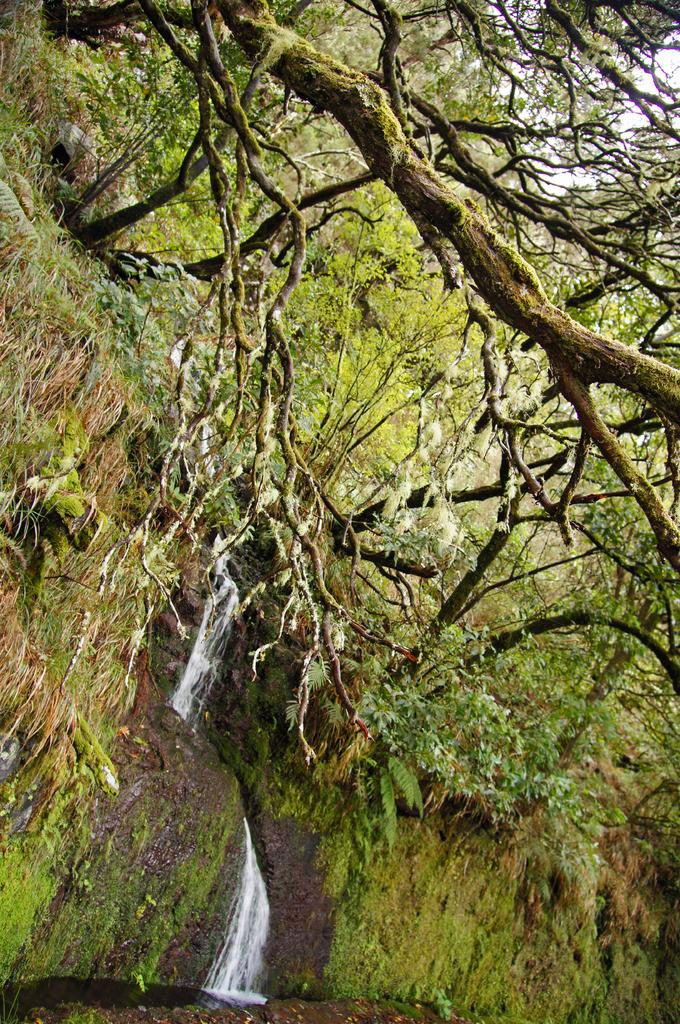What type of vegetation can be seen in the image? There is a group of trees, plants, and grass in the image. What natural feature is located in the middle of the image? There is a waterfall in the middle of the image. What part of the sky is visible in the image? The sky is visible in the top right of the image. What type of tax is being discussed by the trees in the image? There are no discussions or taxes present in the image; it features a group of trees, plants, grass, a waterfall, and a visible sky. 